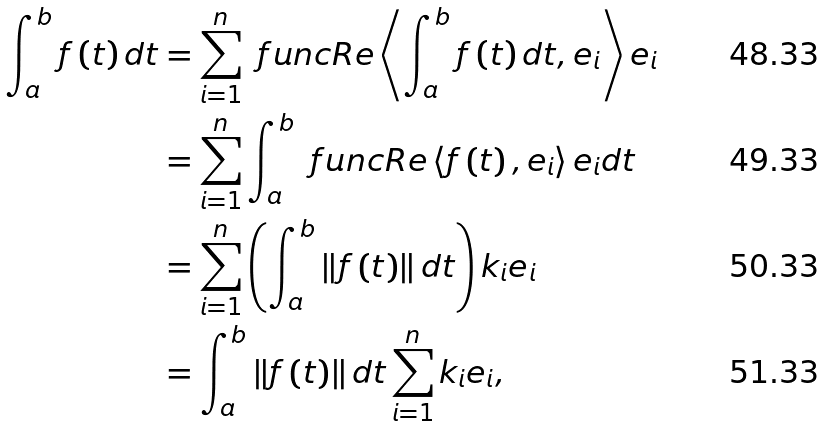Convert formula to latex. <formula><loc_0><loc_0><loc_500><loc_500>\int _ { a } ^ { b } f \left ( t \right ) d t & = \sum _ { i = 1 } ^ { n } \ f u n c { R e } \left \langle \int _ { a } ^ { b } f \left ( t \right ) d t , e _ { i } \right \rangle e _ { i } \\ & = \sum _ { i = 1 } ^ { n } \int _ { a } ^ { b } \ f u n c { R e } \left \langle f \left ( t \right ) , e _ { i } \right \rangle e _ { i } d t \\ & = \sum _ { i = 1 } ^ { n } \left ( \int _ { a } ^ { b } \left \| f \left ( t \right ) \right \| d t \right ) k _ { i } e _ { i } \\ & = \int _ { a } ^ { b } \left \| f \left ( t \right ) \right \| d t \sum _ { i = 1 } ^ { n } k _ { i } e _ { i } ,</formula> 